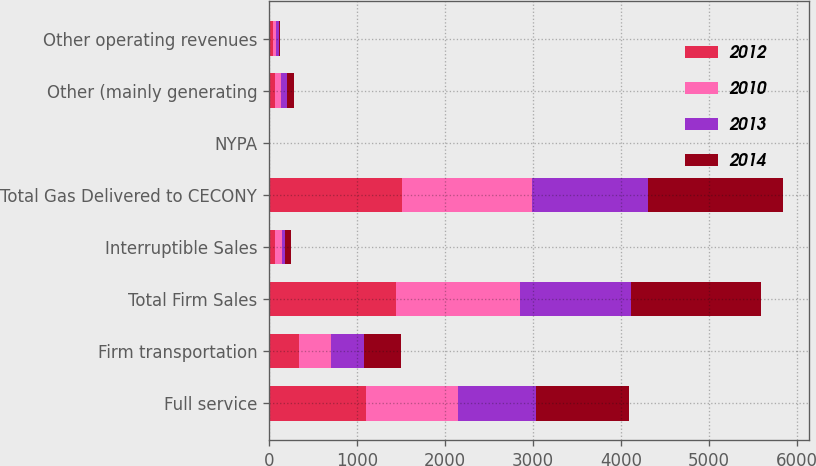<chart> <loc_0><loc_0><loc_500><loc_500><stacked_bar_chart><ecel><fcel>Full service<fcel>Firm transportation<fcel>Total Firm Sales<fcel>Interruptible Sales<fcel>Total Gas Delivered to CECONY<fcel>NYPA<fcel>Other (mainly generating<fcel>Other operating revenues<nl><fcel>2012<fcel>1099<fcel>347<fcel>1446<fcel>72<fcel>1518<fcel>2<fcel>71<fcel>50<nl><fcel>2010<fcel>1048<fcel>356<fcel>1404<fcel>74<fcel>1478<fcel>2<fcel>71<fcel>30<nl><fcel>2013<fcel>889<fcel>380<fcel>1269<fcel>39<fcel>1308<fcel>2<fcel>68<fcel>32<nl><fcel>2014<fcel>1059<fcel>414<fcel>1473<fcel>69<fcel>1542<fcel>2<fcel>71<fcel>17<nl></chart> 